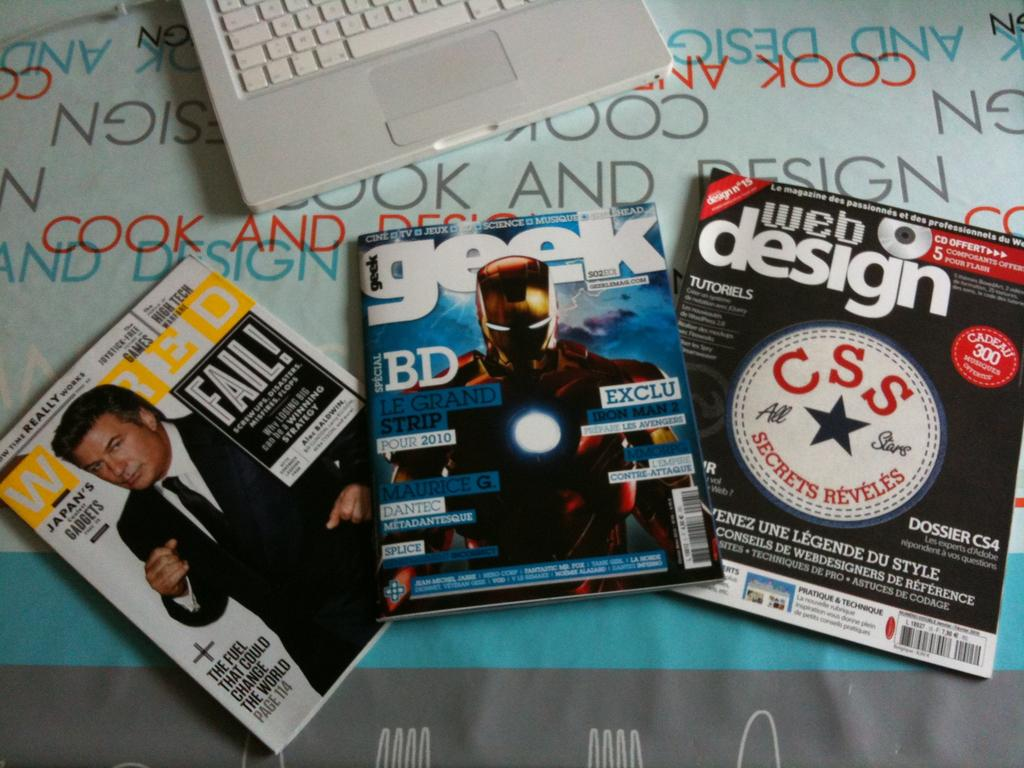<image>
Share a concise interpretation of the image provided. Web Design, Wired and Geek are the titles of these three magazines. 